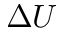<formula> <loc_0><loc_0><loc_500><loc_500>\Delta U</formula> 